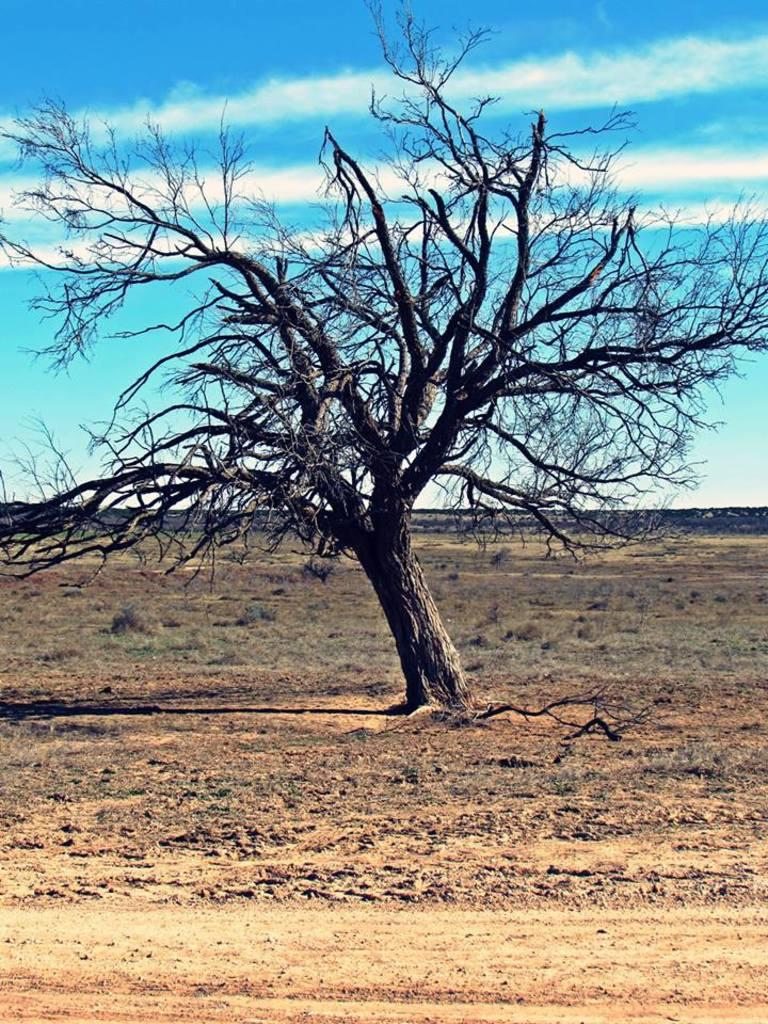What type of natural elements can be seen in the image? There are trees in the image. What part of the natural environment is visible in the image? The sky is visible in the image. What type of organization is depicted in the cave in the image? There is no cave or organization present in the image; it only features trees and the sky. 